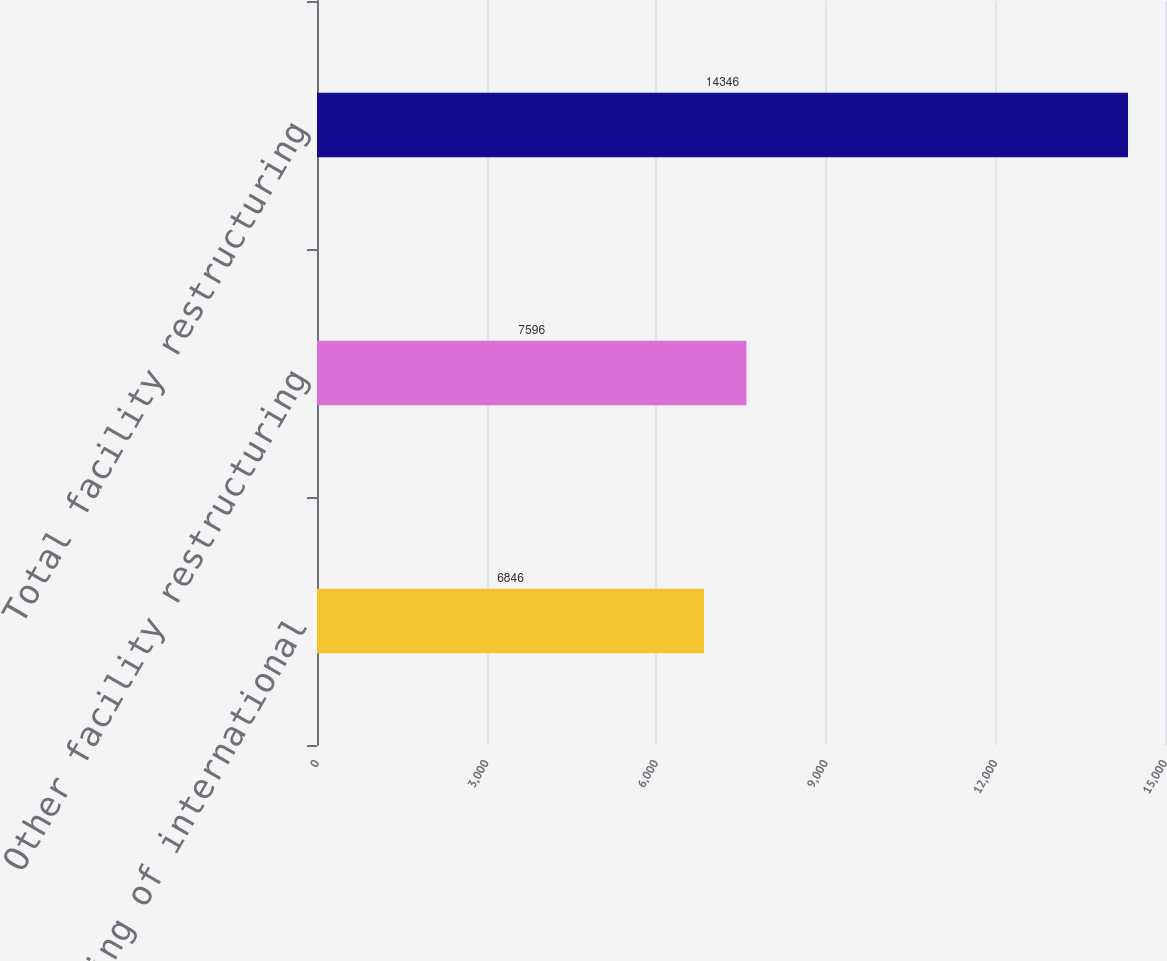Convert chart. <chart><loc_0><loc_0><loc_500><loc_500><bar_chart><fcel>Restructuring of international<fcel>Other facility restructuring<fcel>Total facility restructuring<nl><fcel>6846<fcel>7596<fcel>14346<nl></chart> 